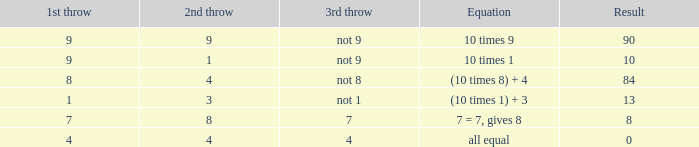What is the result when the 3rd throw is not 8? 84.0. 